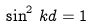<formula> <loc_0><loc_0><loc_500><loc_500>\sin ^ { 2 } \, k d = 1</formula> 